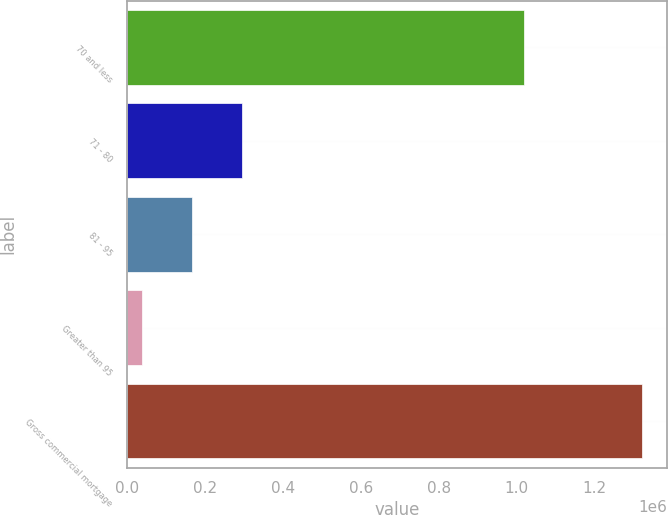Convert chart. <chart><loc_0><loc_0><loc_500><loc_500><bar_chart><fcel>70 and less<fcel>71 - 80<fcel>81 - 95<fcel>Greater than 95<fcel>Gross commercial mortgage<nl><fcel>1.01893e+06<fcel>294177<fcel>165937<fcel>37697<fcel>1.3201e+06<nl></chart> 